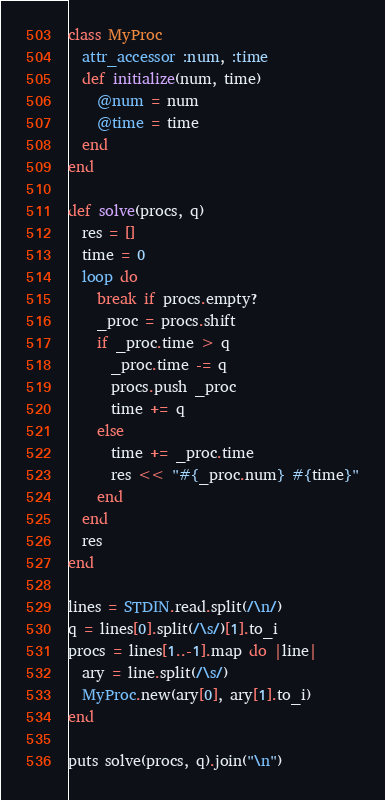Convert code to text. <code><loc_0><loc_0><loc_500><loc_500><_Ruby_>class MyProc
  attr_accessor :num, :time
  def initialize(num, time)
    @num = num 
    @time = time 
  end
end

def solve(procs, q)
  res = []
  time = 0
  loop do
    break if procs.empty?
    _proc = procs.shift
    if _proc.time > q
      _proc.time -= q
      procs.push _proc
      time += q
    else
      time += _proc.time
      res << "#{_proc.num} #{time}"
    end
  end
  res
end

lines = STDIN.read.split(/\n/)
q = lines[0].split(/\s/)[1].to_i
procs = lines[1..-1].map do |line|
  ary = line.split(/\s/)
  MyProc.new(ary[0], ary[1].to_i)
end

puts solve(procs, q).join("\n")</code> 